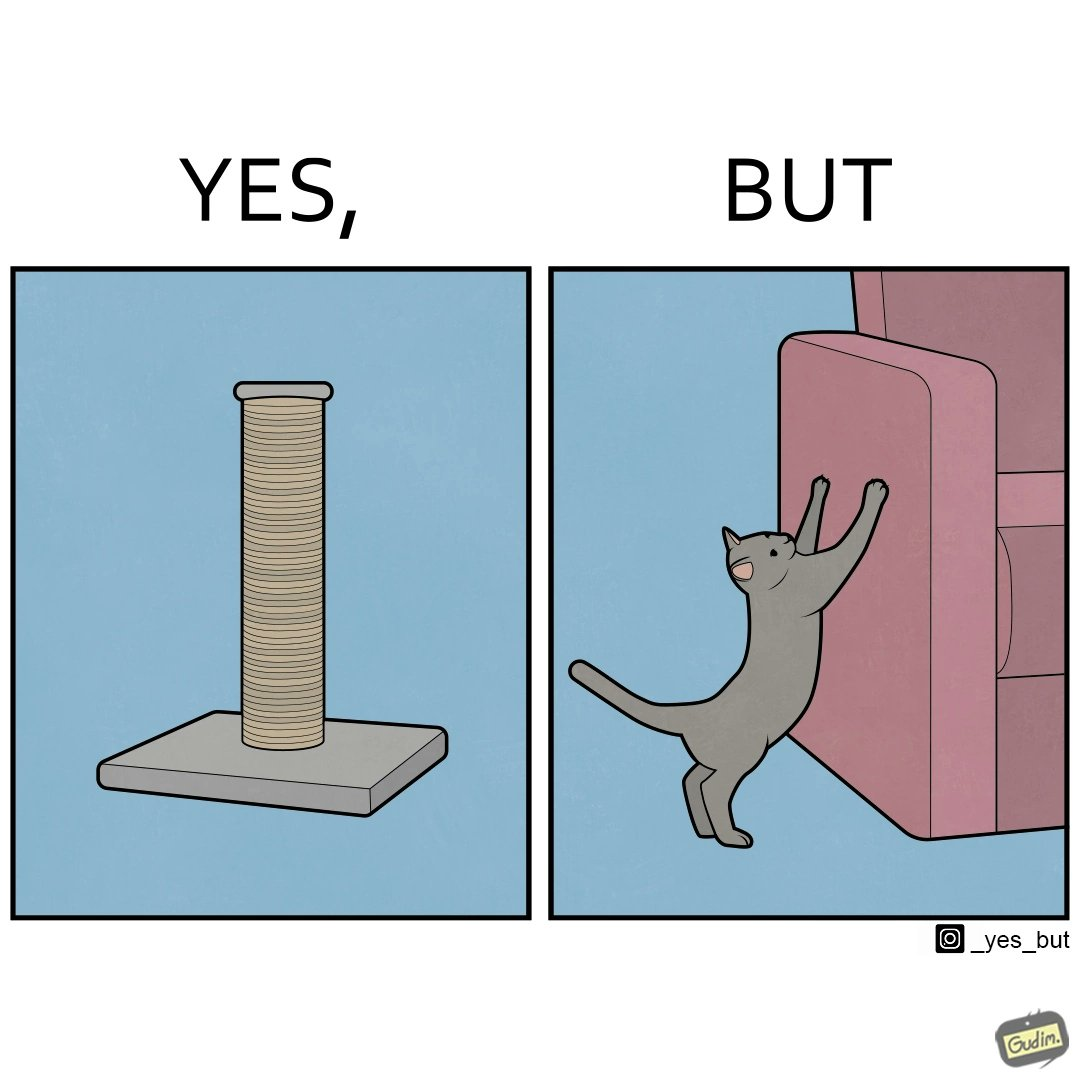Explain why this image is satirical. The image is ironic, because in the first image a toy, purposed for the cat to play with is shown but in the second image the cat is comfortably enjoying  to play on the sides of sofa 